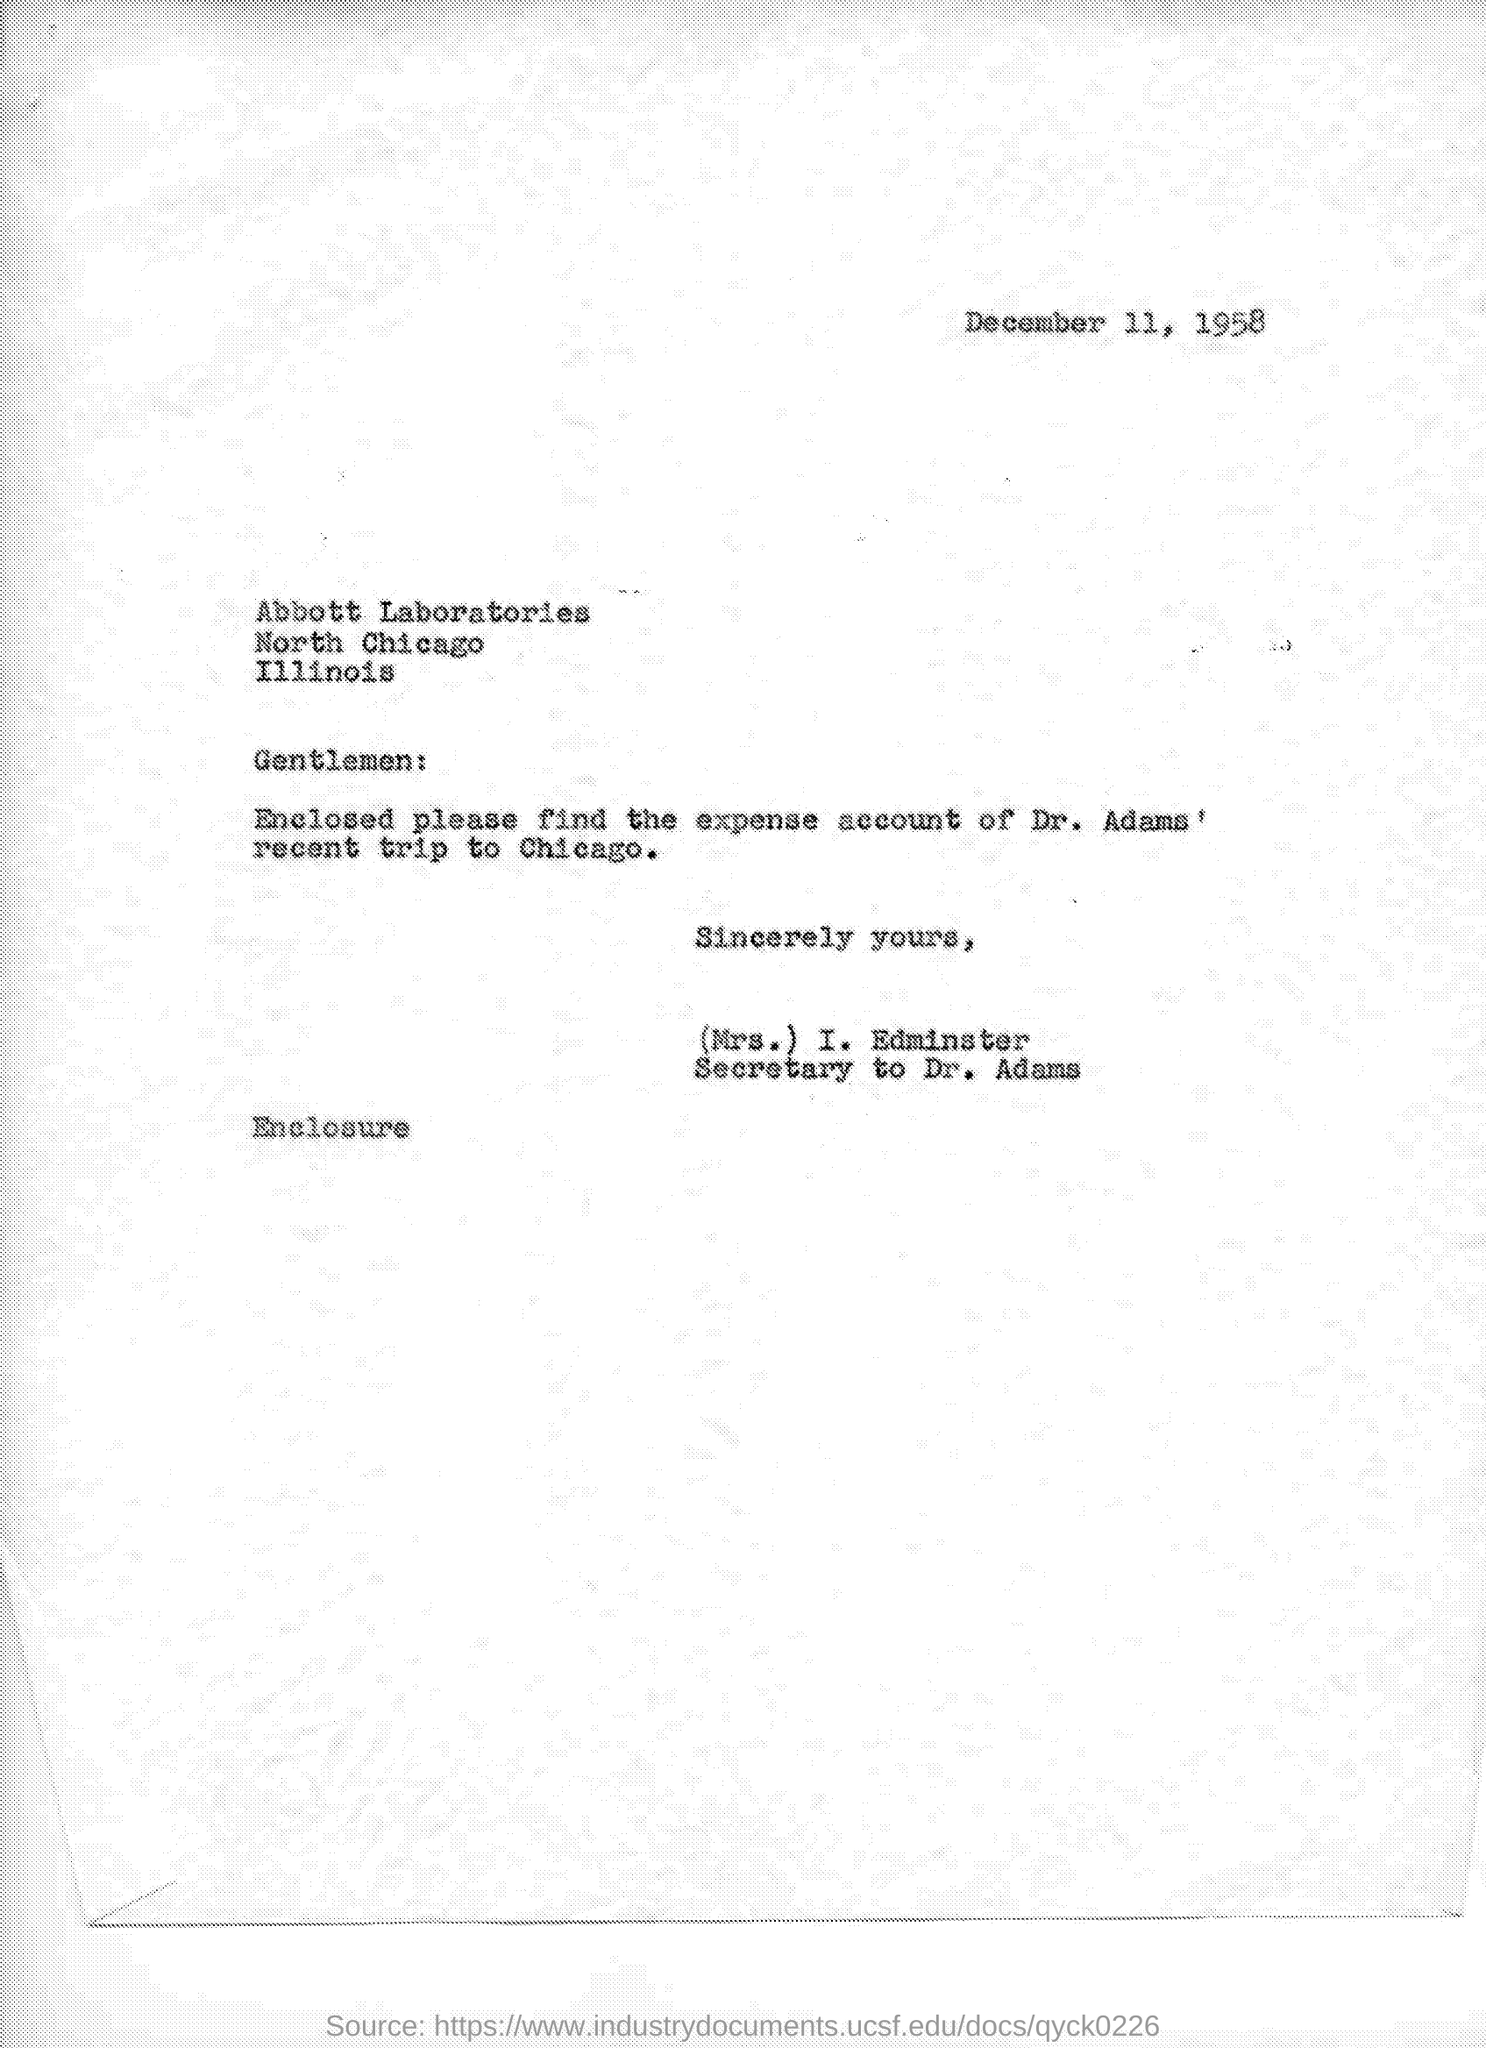Give some essential details in this illustration. The letter is from Mrs. I. Edminster. The date is December 11, 1958. The enclosed expense account belongs to Dr. Adams who recently visited Chicago. 